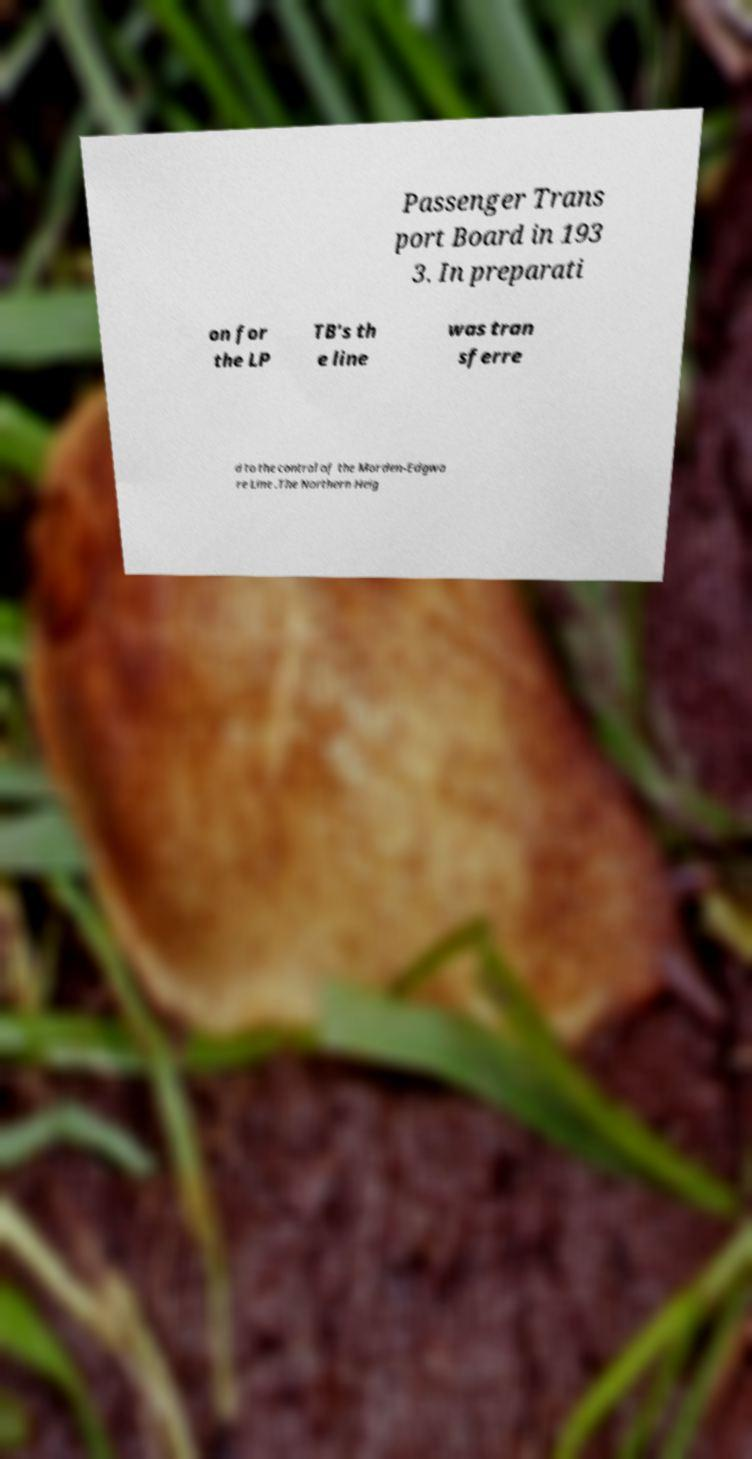Could you assist in decoding the text presented in this image and type it out clearly? Passenger Trans port Board in 193 3. In preparati on for the LP TB's th e line was tran sferre d to the control of the Morden-Edgwa re Line .The Northern Heig 